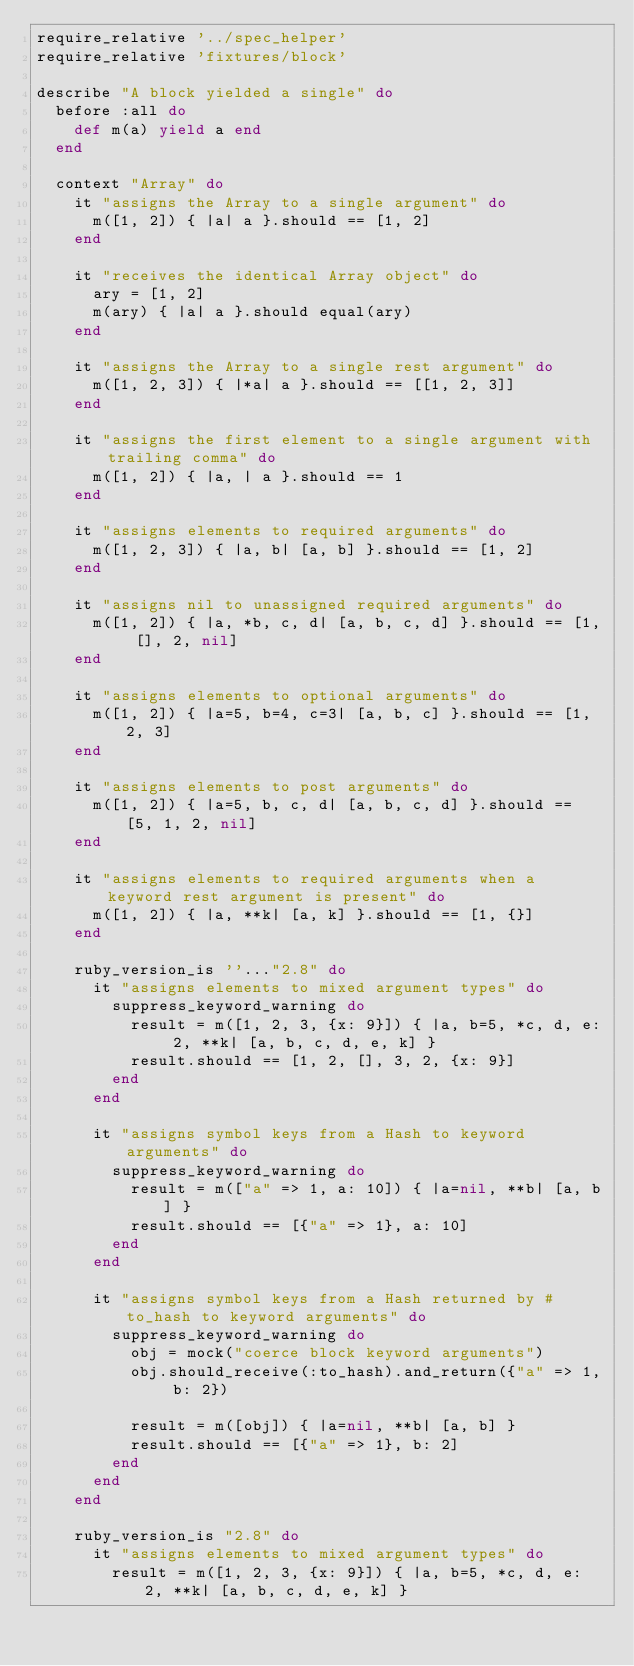Convert code to text. <code><loc_0><loc_0><loc_500><loc_500><_Ruby_>require_relative '../spec_helper'
require_relative 'fixtures/block'

describe "A block yielded a single" do
  before :all do
    def m(a) yield a end
  end

  context "Array" do
    it "assigns the Array to a single argument" do
      m([1, 2]) { |a| a }.should == [1, 2]
    end

    it "receives the identical Array object" do
      ary = [1, 2]
      m(ary) { |a| a }.should equal(ary)
    end

    it "assigns the Array to a single rest argument" do
      m([1, 2, 3]) { |*a| a }.should == [[1, 2, 3]]
    end

    it "assigns the first element to a single argument with trailing comma" do
      m([1, 2]) { |a, | a }.should == 1
    end

    it "assigns elements to required arguments" do
      m([1, 2, 3]) { |a, b| [a, b] }.should == [1, 2]
    end

    it "assigns nil to unassigned required arguments" do
      m([1, 2]) { |a, *b, c, d| [a, b, c, d] }.should == [1, [], 2, nil]
    end

    it "assigns elements to optional arguments" do
      m([1, 2]) { |a=5, b=4, c=3| [a, b, c] }.should == [1, 2, 3]
    end

    it "assigns elements to post arguments" do
      m([1, 2]) { |a=5, b, c, d| [a, b, c, d] }.should == [5, 1, 2, nil]
    end

    it "assigns elements to required arguments when a keyword rest argument is present" do
      m([1, 2]) { |a, **k| [a, k] }.should == [1, {}]
    end

    ruby_version_is ''..."2.8" do
      it "assigns elements to mixed argument types" do
        suppress_keyword_warning do
          result = m([1, 2, 3, {x: 9}]) { |a, b=5, *c, d, e: 2, **k| [a, b, c, d, e, k] }
          result.should == [1, 2, [], 3, 2, {x: 9}]
        end
      end

      it "assigns symbol keys from a Hash to keyword arguments" do
        suppress_keyword_warning do
          result = m(["a" => 1, a: 10]) { |a=nil, **b| [a, b] }
          result.should == [{"a" => 1}, a: 10]
        end
      end

      it "assigns symbol keys from a Hash returned by #to_hash to keyword arguments" do
        suppress_keyword_warning do
          obj = mock("coerce block keyword arguments")
          obj.should_receive(:to_hash).and_return({"a" => 1, b: 2})

          result = m([obj]) { |a=nil, **b| [a, b] }
          result.should == [{"a" => 1}, b: 2]
        end
      end
    end

    ruby_version_is "2.8" do
      it "assigns elements to mixed argument types" do
        result = m([1, 2, 3, {x: 9}]) { |a, b=5, *c, d, e: 2, **k| [a, b, c, d, e, k] }</code> 